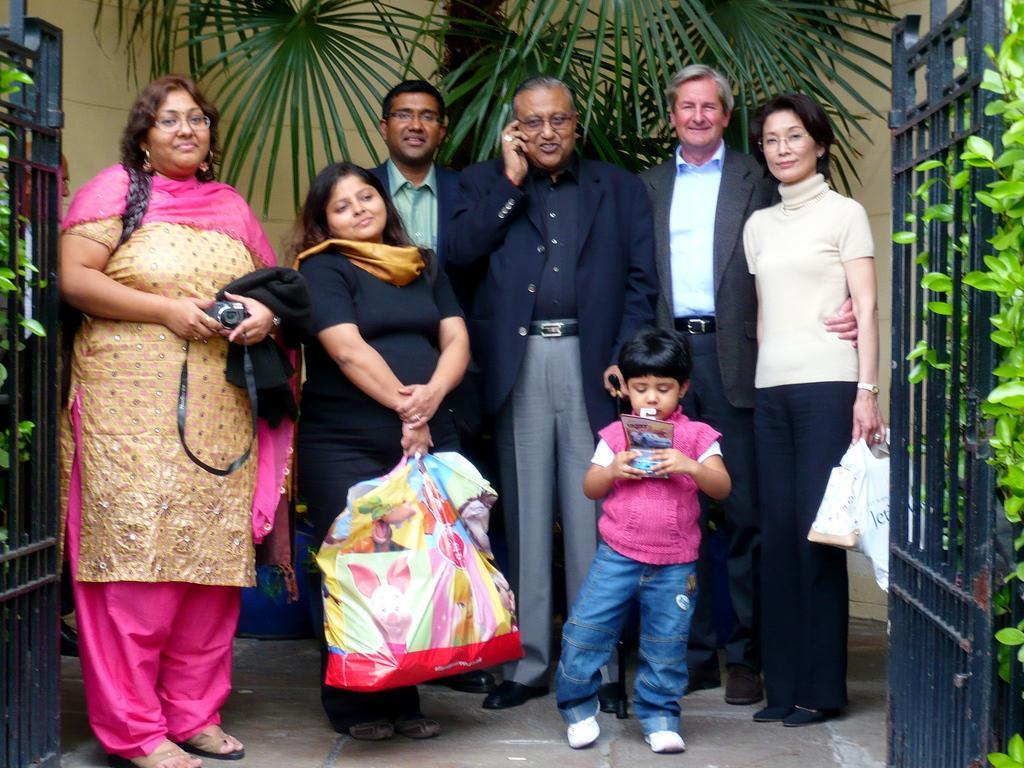Can you describe this image briefly? In this image, we can see a group of people are standing. Few are smiling and holding objects. Here we can see plants, grills, tree. Background there is a wall. 